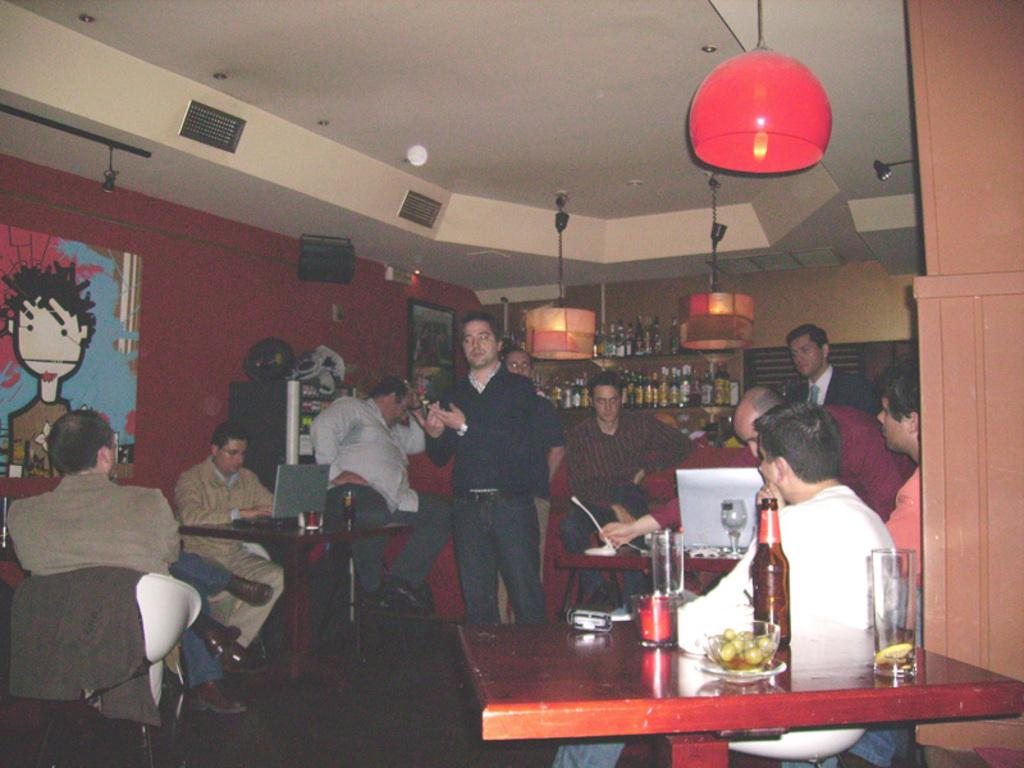How many people are in the image? There is a group of people in the people in the image. What are the people doing in the image? The people are sitting in front of a table. What objects can be seen on the table? There is a glass, a bottle, and a bowl on the table. What is located at the back of the image? There is a wine rack at the back of the image. What type of pot is visible on the table in the image? There is no pot visible on the table in the image. Can you tell me how many airplanes are parked at the airport in the image? There is no airport or airplanes present in the image. 